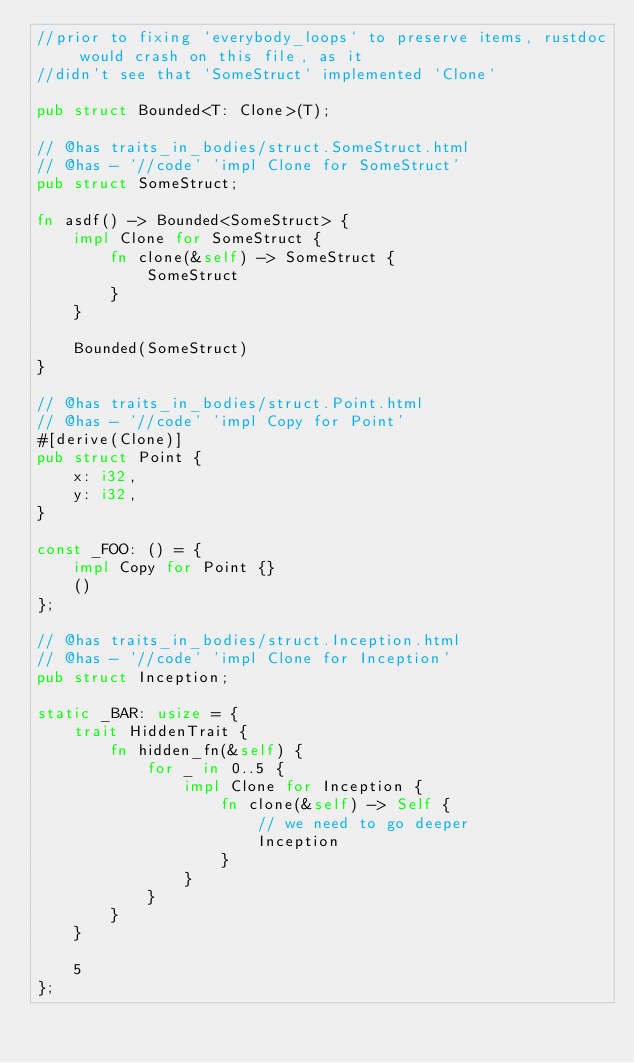Convert code to text. <code><loc_0><loc_0><loc_500><loc_500><_Rust_>//prior to fixing `everybody_loops` to preserve items, rustdoc would crash on this file, as it
//didn't see that `SomeStruct` implemented `Clone`

pub struct Bounded<T: Clone>(T);

// @has traits_in_bodies/struct.SomeStruct.html
// @has - '//code' 'impl Clone for SomeStruct'
pub struct SomeStruct;

fn asdf() -> Bounded<SomeStruct> {
    impl Clone for SomeStruct {
        fn clone(&self) -> SomeStruct {
            SomeStruct
        }
    }

    Bounded(SomeStruct)
}

// @has traits_in_bodies/struct.Point.html
// @has - '//code' 'impl Copy for Point'
#[derive(Clone)]
pub struct Point {
    x: i32,
    y: i32,
}

const _FOO: () = {
    impl Copy for Point {}
    ()
};

// @has traits_in_bodies/struct.Inception.html
// @has - '//code' 'impl Clone for Inception'
pub struct Inception;

static _BAR: usize = {
    trait HiddenTrait {
        fn hidden_fn(&self) {
            for _ in 0..5 {
                impl Clone for Inception {
                    fn clone(&self) -> Self {
                        // we need to go deeper
                        Inception
                    }
                }
            }
        }
    }

    5
};
</code> 